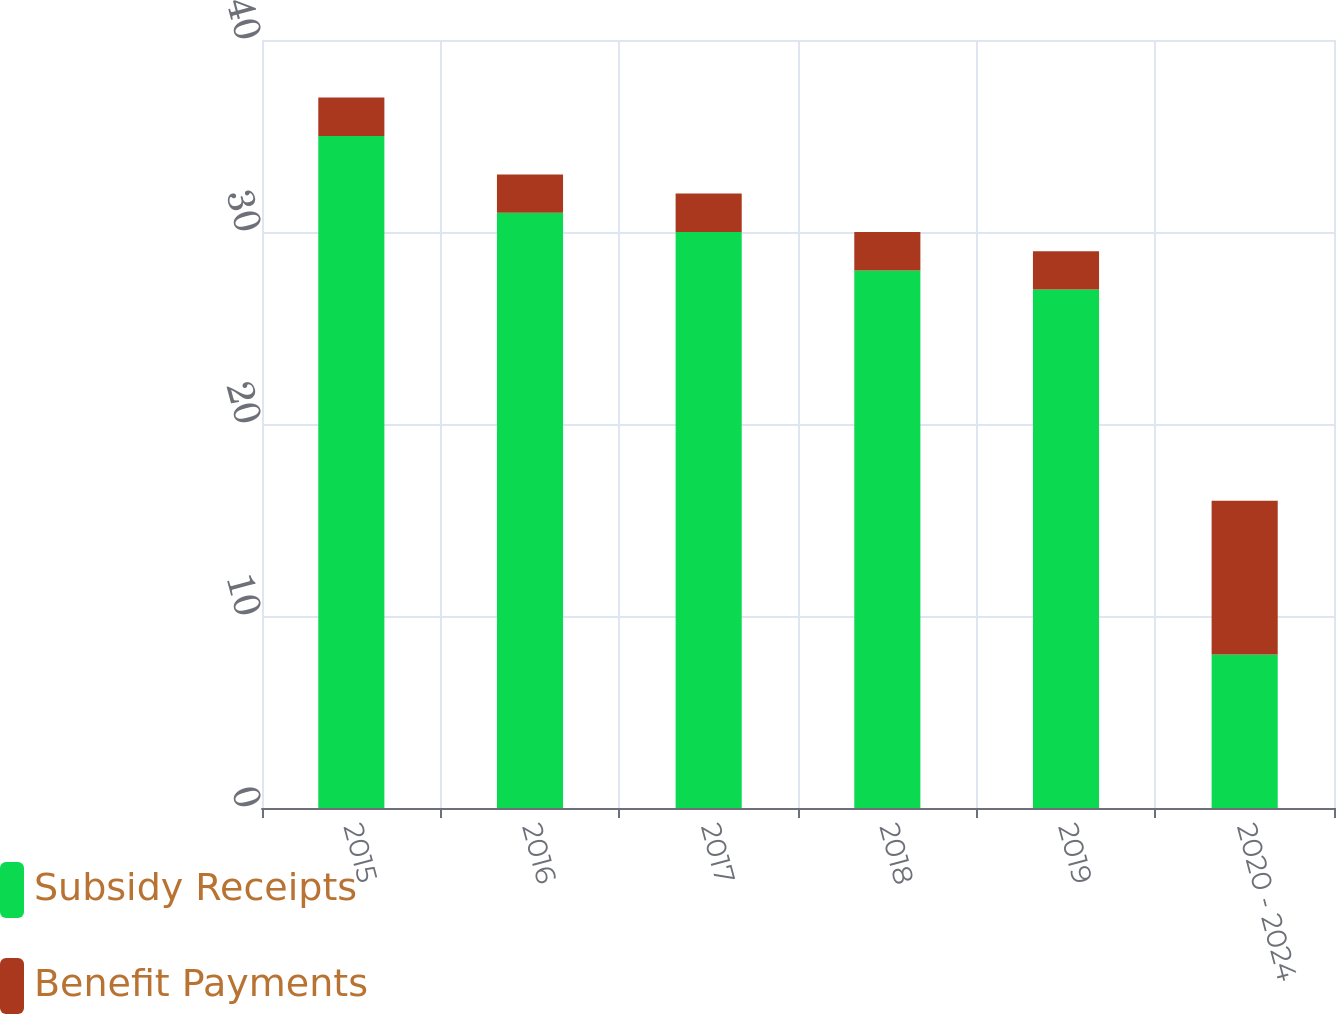<chart> <loc_0><loc_0><loc_500><loc_500><stacked_bar_chart><ecel><fcel>2015<fcel>2016<fcel>2017<fcel>2018<fcel>2019<fcel>2020 - 2024<nl><fcel>Subsidy Receipts<fcel>35<fcel>31<fcel>30<fcel>28<fcel>27<fcel>8<nl><fcel>Benefit Payments<fcel>2<fcel>2<fcel>2<fcel>2<fcel>2<fcel>8<nl></chart> 